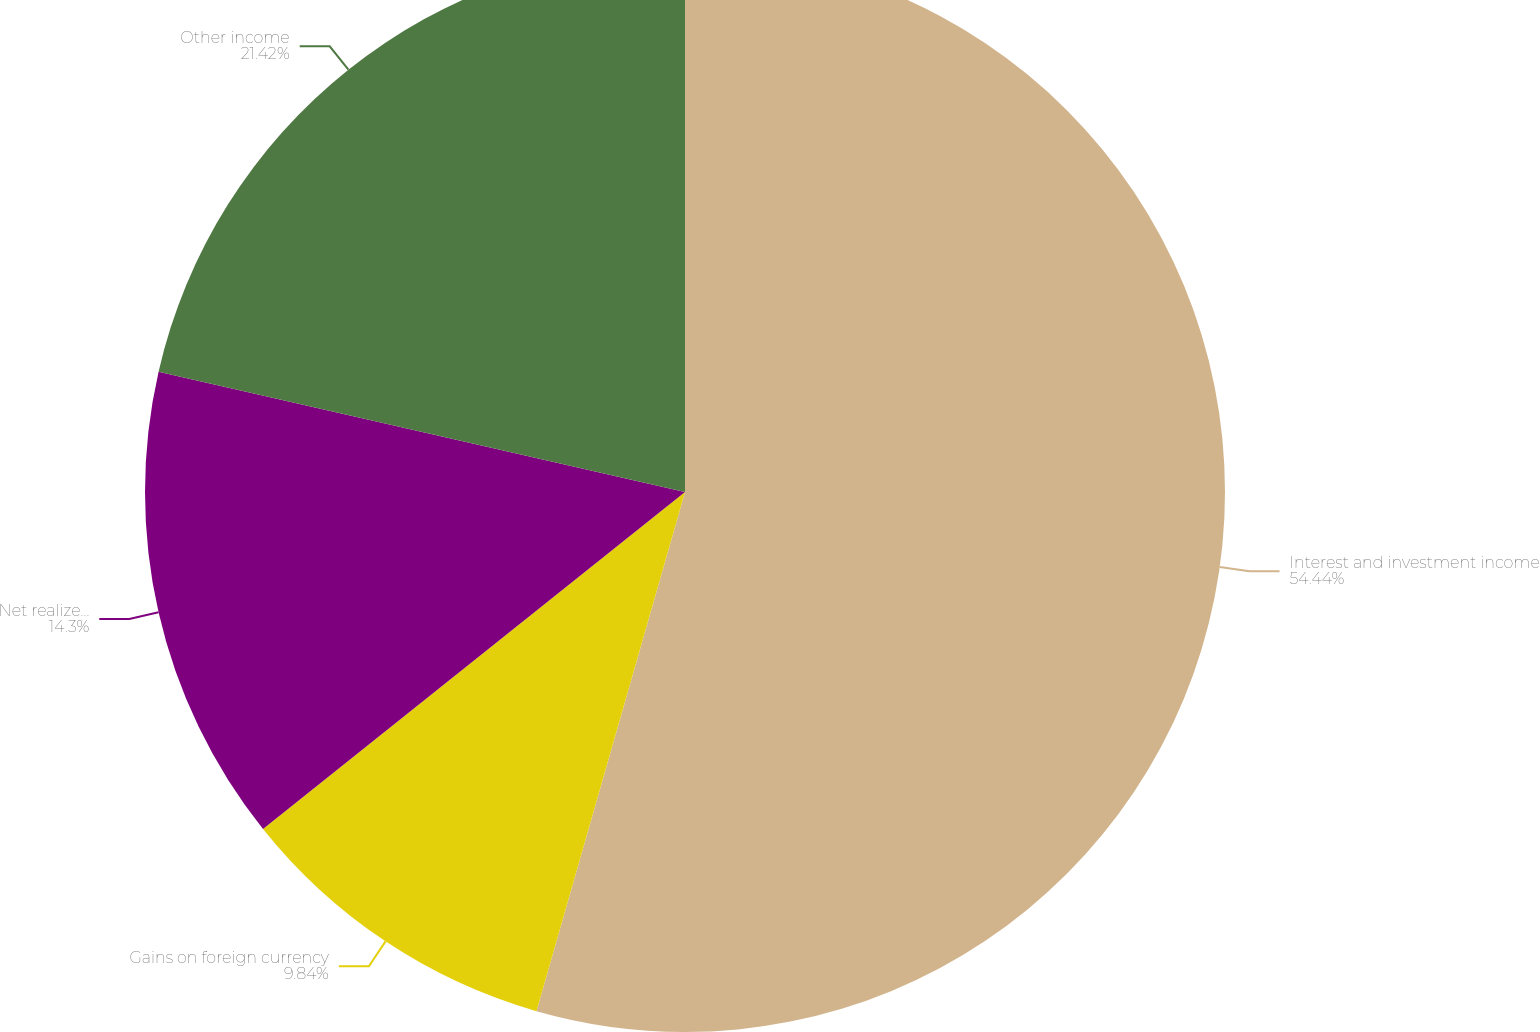<chart> <loc_0><loc_0><loc_500><loc_500><pie_chart><fcel>Interest and investment income<fcel>Gains on foreign currency<fcel>Net realized gains on sales of<fcel>Other income<nl><fcel>54.43%<fcel>9.84%<fcel>14.3%<fcel>21.42%<nl></chart> 